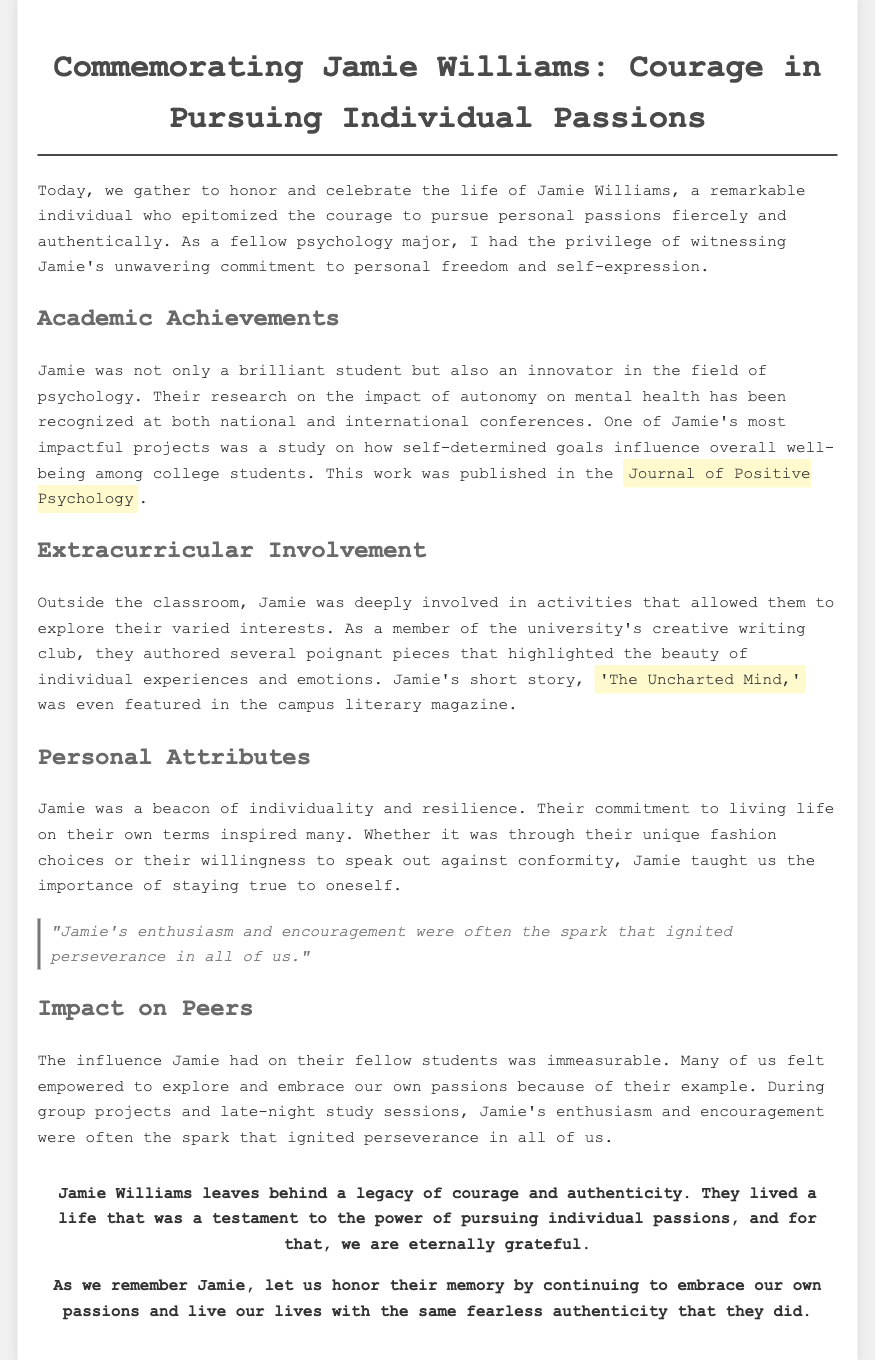What was Jamie Williams' major? The document states that Jamie was a fellow psychology major, indicating their field of study.
Answer: Psychology What was the title of Jamie's published research? The document mentions that Jamie's research was published in the Journal of Positive Psychology, but the specific title is not provided.
Answer: Impact of autonomy on mental health What was the title of Jamie's short story? The document highlights Jamie's short story as being featured in the campus literary magazine with the title 'The Uncharted Mind.'
Answer: The Uncharted Mind In how many conferences was Jamie's research recognized? The document mentions that Jamie's research has been recognized at both national and international conferences, which indicates the scale of recognition.
Answer: Two What did Jamie inspire in their peers? The eulogy states that Jamie empowered their fellow students to explore and embrace their own passions, indicating Jamie's motivational impact.
Answer: Exploration of passions What is one personal attribute of Jamie mentioned in the document? The eulogy describes Jamie as a beacon of individuality and resilience, highlighting their character traits.
Answer: Individuality What was Jamie's role in extracurricular activities? The document explains that Jamie was a member of the university's creative writing club, showing their involvement outside academics.
Answer: Creative writing What legacy did Jamie Williams leave behind? The eulogy concludes that Jamie Williams leaves behind a legacy of courage and authenticity, reflecting their impact.
Answer: Courage and authenticity 